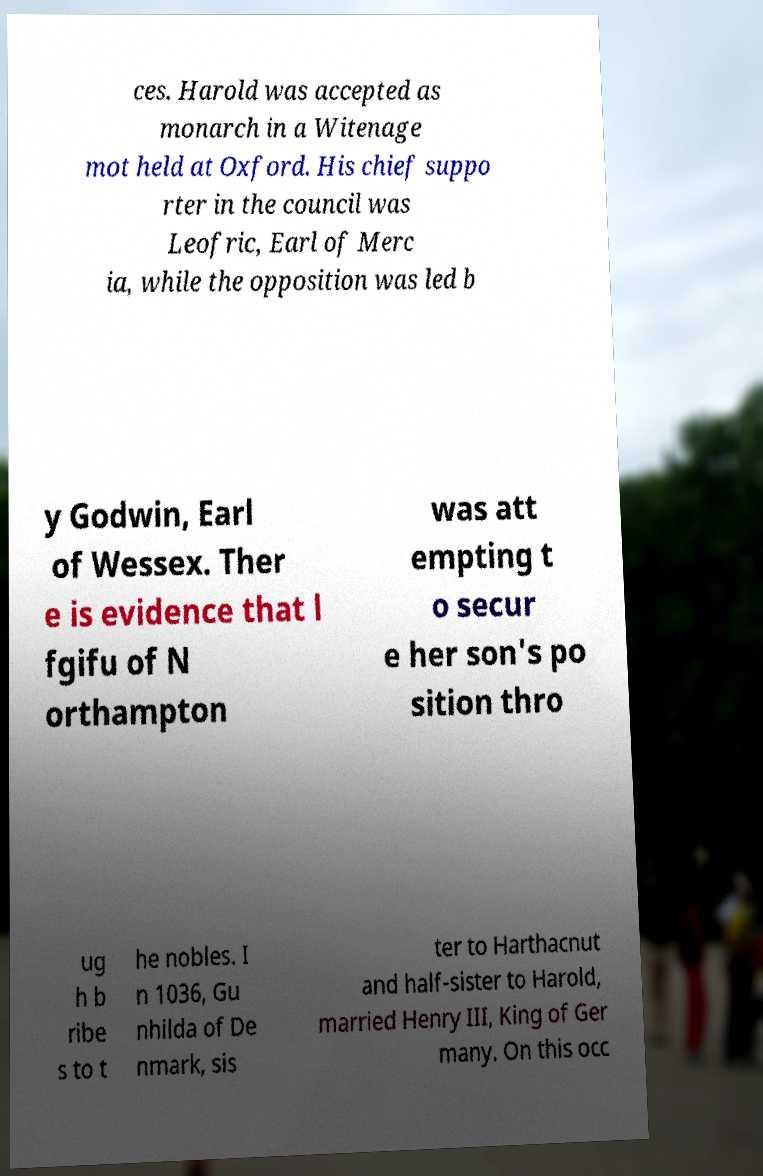Could you assist in decoding the text presented in this image and type it out clearly? ces. Harold was accepted as monarch in a Witenage mot held at Oxford. His chief suppo rter in the council was Leofric, Earl of Merc ia, while the opposition was led b y Godwin, Earl of Wessex. Ther e is evidence that l fgifu of N orthampton was att empting t o secur e her son's po sition thro ug h b ribe s to t he nobles. I n 1036, Gu nhilda of De nmark, sis ter to Harthacnut and half-sister to Harold, married Henry III, King of Ger many. On this occ 